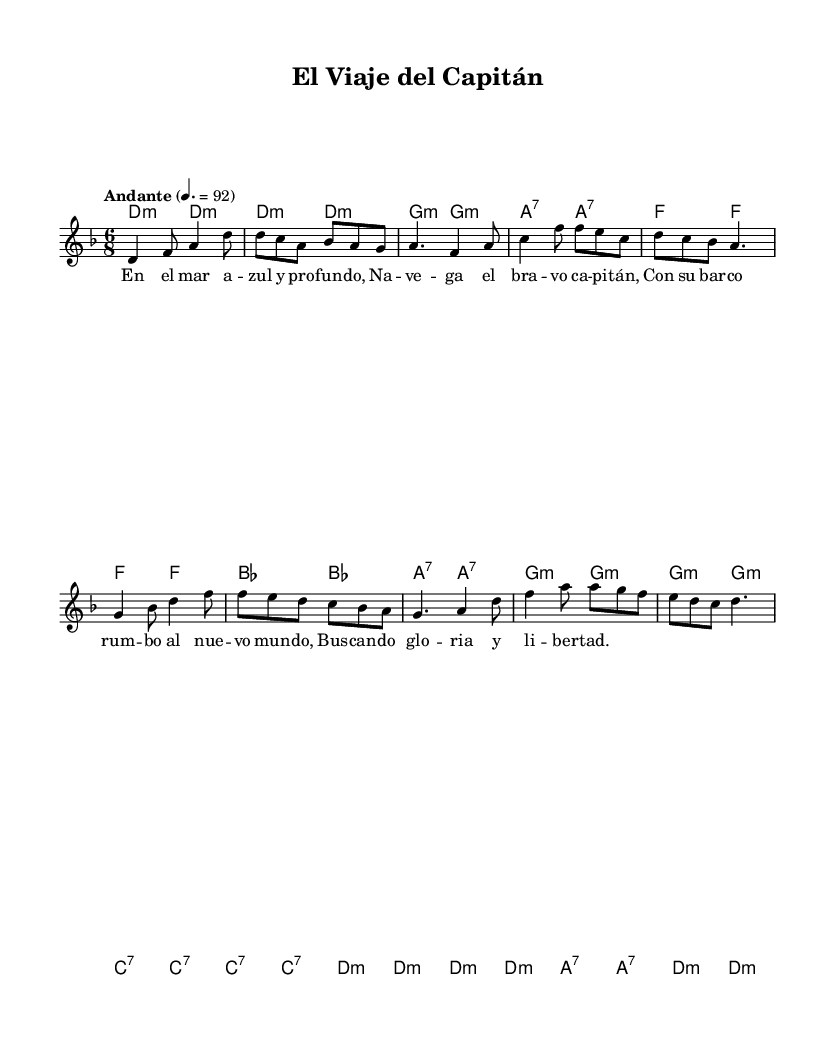What is the key signature of this music? The key signature is indicated at the beginning of the score and shows 1 flat, which corresponds to the key of D minor.
Answer: D minor What is the time signature of the piece? The time signature is located at the beginning of the score and is written as 6/8, which indicates there are six eighth notes per measure.
Answer: 6/8 What is the tempo marking of this piece? The tempo marking is found in the beginning section of the score and states "Andante" at a speed of quarter note equals 92, indicating a moderate pace.
Answer: Andante How many measures are in the melody? By counting the bars in the melody section visually, there are 12 measures in total.
Answer: 12 Which chord appears the most frequently in the harmonies? The chord analysis shows that the D minor chord is played in every pair of measures, making it the most recurring harmony throughout the score.
Answer: D minor Describe the lyrical theme of the song. The lyrics evoke themes of maritime adventure, focusing on a brave captain sailing in search of glory and freedom across the sea, which aligns well with Latin American folk traditions.
Answer: Maritime adventure What type of song is "El Viaje del Capitán"? The song typifies a folk song as it tells a story through its lyrics and is characterized by its traditional and cultural themes prevalent in Latin American music.
Answer: Folk song 